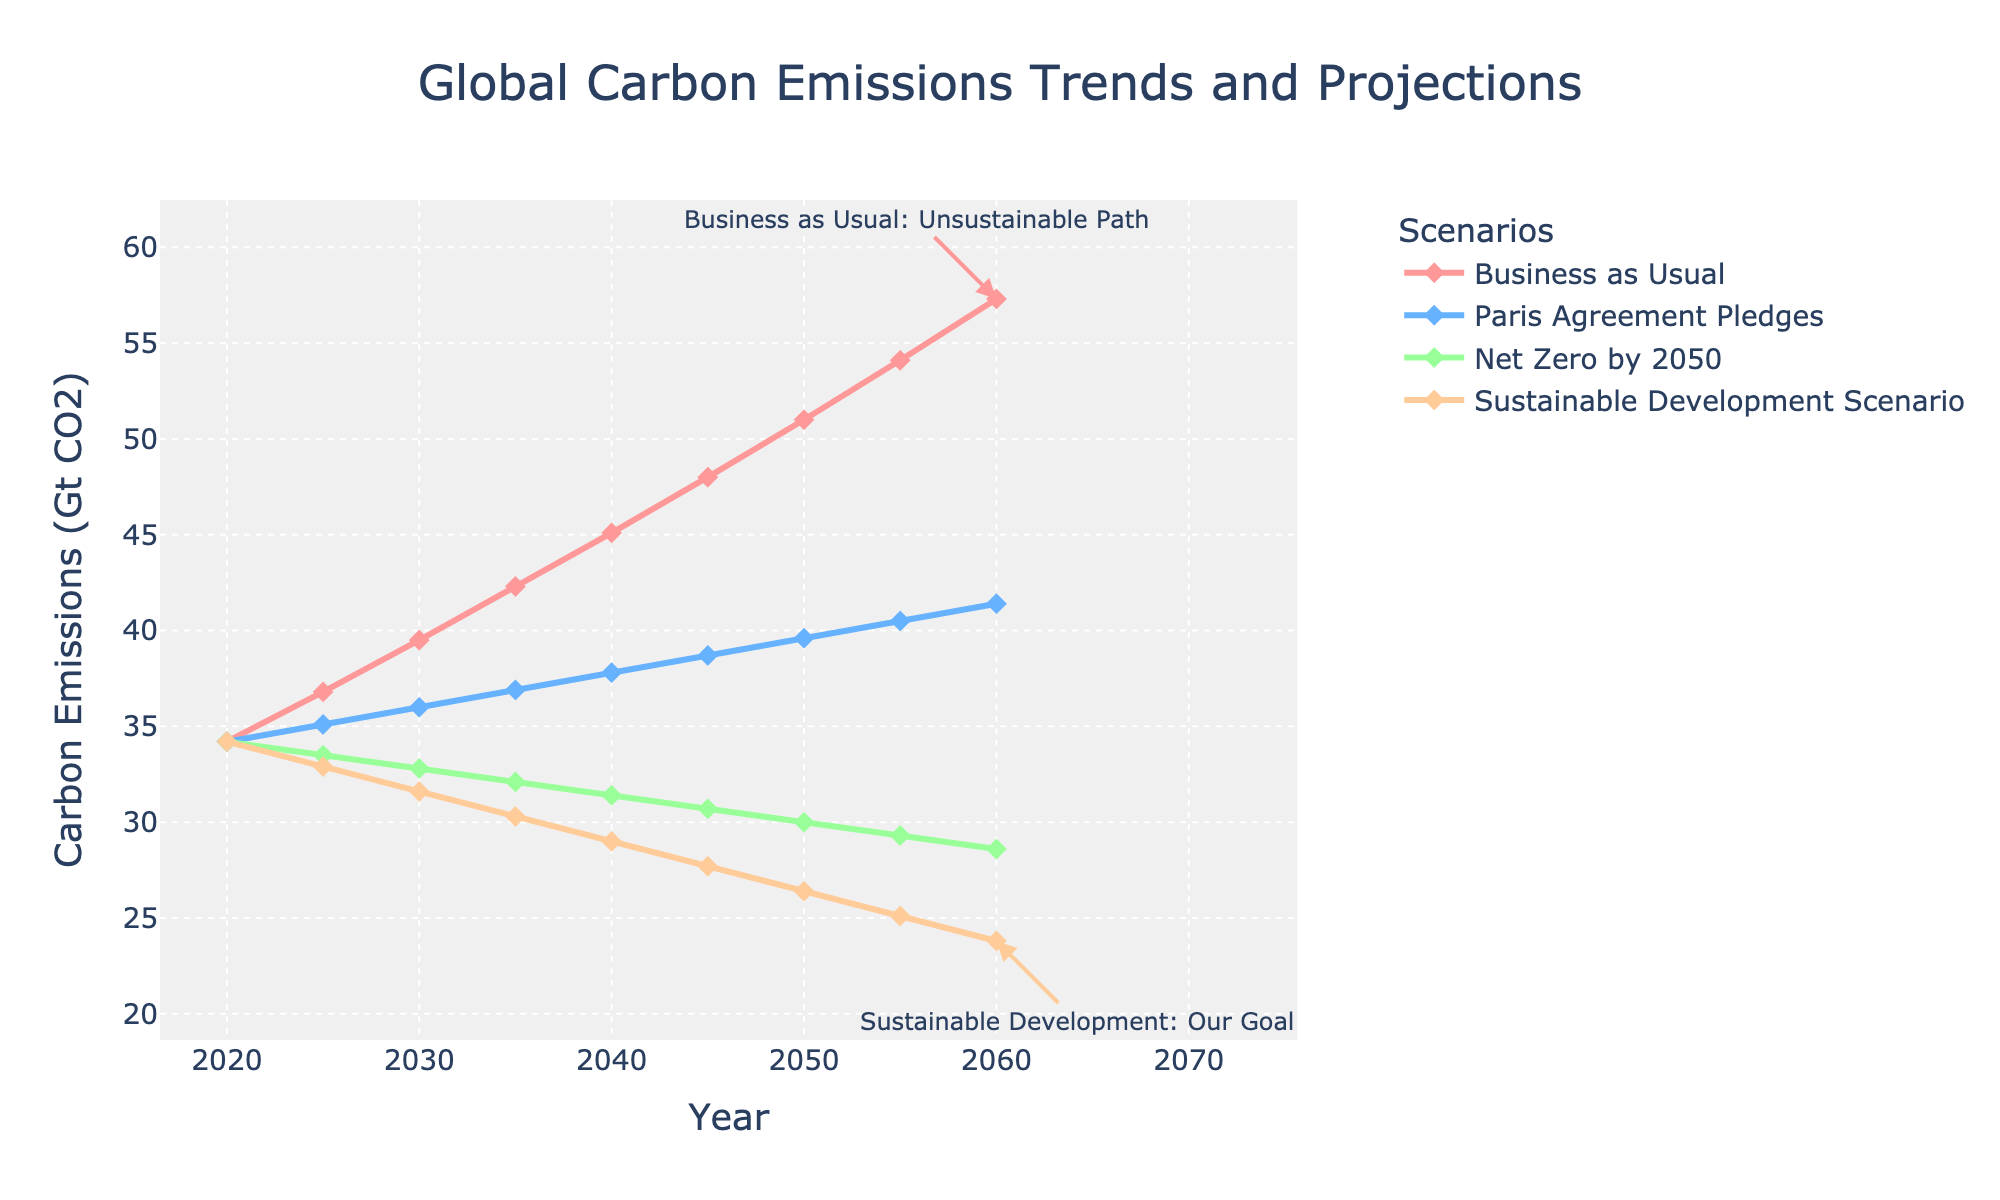What is the projected carbon emission by 2050 in the Sustainable Development Scenario compared to the Business as Usual scenario? The Sustainable Development Scenario projects 26.4 Gt CO2 by 2050 and the Business as Usual projects 51.0 Gt CO2. These projections are indicated by the points on the 2050 vertical line.
Answer: 26.4 Gt CO2 for Sustainable Development, 51.0 Gt CO2 for Business as Usual How much do the Paris Agreement Pledges reduce carbon emissions by 2035 compared to Business as Usual? In 2035, Business as Usual is projected at 42.3 Gt CO2 and Paris Agreement Pledges at 36.9 Gt CO2. The reduction is calculated as 42.3 - 36.9 = 5.4 Gt CO2.
Answer: 5.4 Gt CO2 Which scenario shows the steepest decline in carbon emissions from 2020 to 2060? By comparing the slopes of the lines, the Sustainable Development Scenario line decreases from 34.2 Gt CO2 to 23.8 Gt CO2 from 2020 to 2060. This is a reduction of 34.2 - 23.8 = 10.4 Gt CO2.
Answer: Sustainable Development Scenario What is the annual average reduction rate in carbon emissions for the Net Zero by 2050 scenario from 2020 to 2050? Net Zero by 2050 scenario drops from 34.2 Gt CO2 to 30.0 Gt CO2 in 30 years. The total reduction is 34.2 - 30.0 = 4.2 Gt CO2. Annual average reduction rate is 4.2 / 30 ≈ 0.14 Gt CO2 per year.
Answer: 0.14 Gt CO2 per year Compare the carbon emissions in 2040 under the Net Zero by 2050 and Sustainable Development Scenarios. In 2040, the Net Zero by 2050 scenario shows 31.4 Gt CO2 and the Sustainable Development Scenario shows 29.0 Gt CO2.
Answer: Net Zero by 2050: 31.4 Gt CO2; Sustainable Development: 29.0 Gt CO2 Which scenario keeps carbon emissions relatively stable from 2020 to 2060? The 'Paris Agreement Pledges' scenario shows the smallest increase, moving from 34.2 Gt CO2 in 2020 to 41.4 Gt CO2 in 2060.
Answer: Paris Agreement Pledges By how much would global carbon emissions have to be reduced by 2060 to meet the Sustainable Development Scenario compared to the starting point in 2020? The starting point in 2020 is 34.2 Gt CO2, and for 2060 in the Sustainable Development Scenario, it is 23.8 Gt CO2. The reduction needed is 34.2 - 23.8 = 10.4 Gt CO2.
Answer: 10.4 Gt CO2 What color represents the Net Zero by 2050 scenario in the chart, and what is its approximate emission level in 2025? The color for the Net Zero by 2050 scenario is green, and its emission level in 2025 is around 33.5 Gt CO2.
Answer: Green; 33.5 Gt CO2 